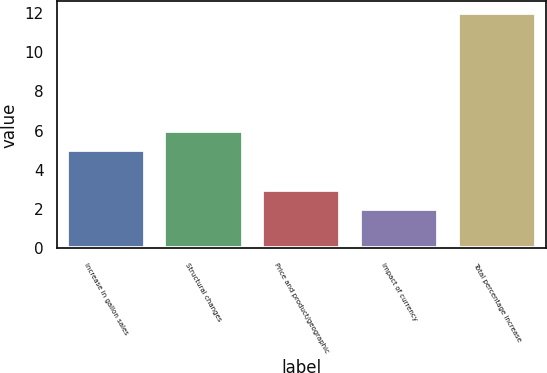<chart> <loc_0><loc_0><loc_500><loc_500><bar_chart><fcel>Increase in gallon sales<fcel>Structural changes<fcel>Price and product/geographic<fcel>Impact of currency<fcel>Total percentage increase<nl><fcel>5<fcel>6<fcel>3<fcel>2<fcel>12<nl></chart> 